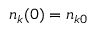Convert formula to latex. <formula><loc_0><loc_0><loc_500><loc_500>n _ { k } ( 0 ) = n _ { k 0 }</formula> 